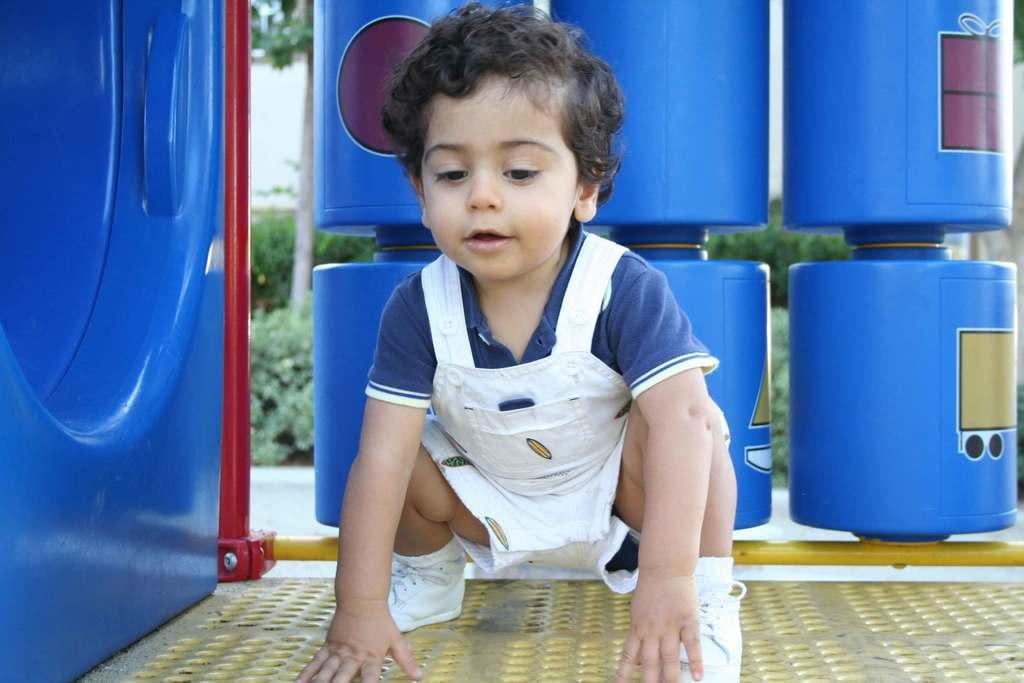What type of vegetation can be seen in the background of the image? There are plants in the background of the image. What color are the objects in the background of the image? There are blue objects in the background of the image. What can be seen in the foreground of the image? There are yellow and red poles in the image. What position is the kid in on the platform? The kid is in a squat position on a platform in the image. How many wheels are visible on the cart in the image? There is no cart present in the image, so it is not possible to determine the number of wheels. 